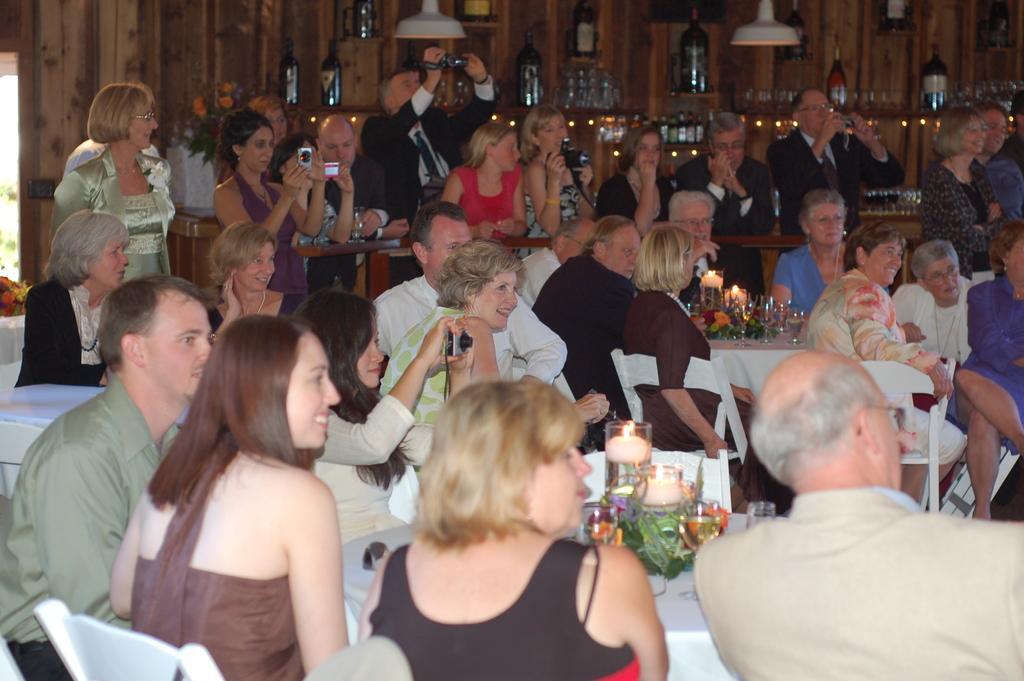How would you summarize this image in a sentence or two? People are sitting on chairs. Few people are standing. These people are holding cameras. Background there are bottles in racks. On these tables there are candles and glasses. These are lights. 